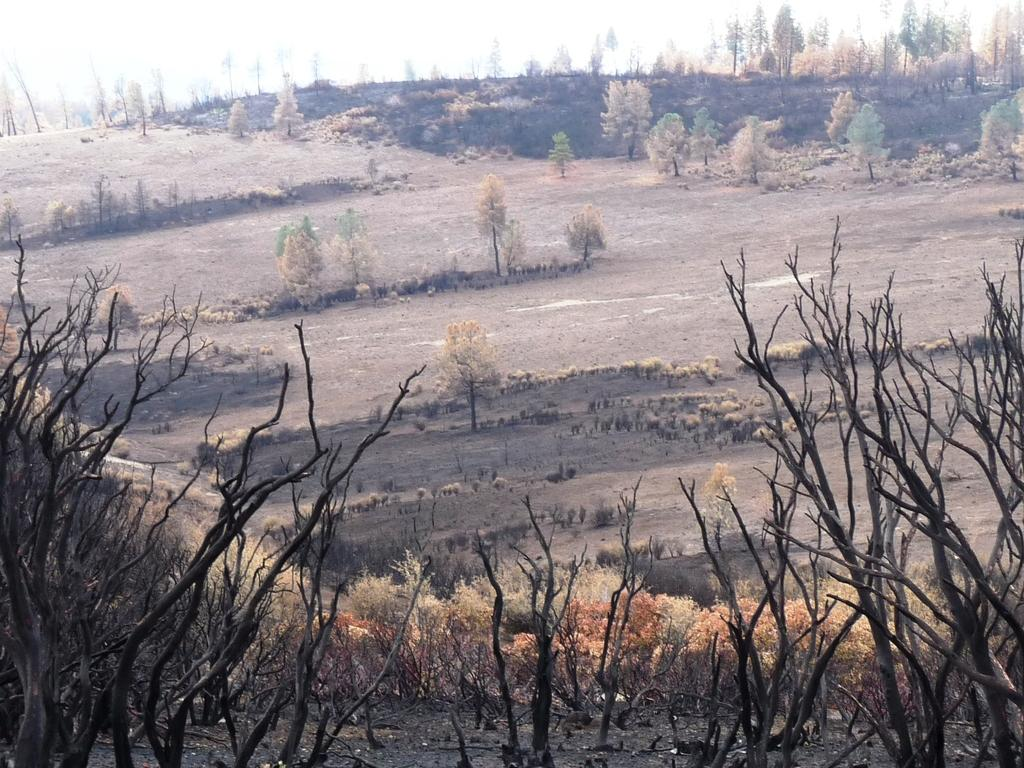What colors can be seen on the trees in the image? The trees in the image have brown and green colors. What is the condition of the trees in the image? The trees in the image are dry. What color is the sky in the image? The sky is white in color. What type of voice can be heard coming from the cub in the image? There is no cub present in the image, so it is not possible to determine what type of voice might be heard. 